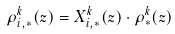<formula> <loc_0><loc_0><loc_500><loc_500>\rho _ { i , * } ^ { k } ( z ) = X _ { i , * } ^ { k } ( z ) \cdot \rho _ { * } ^ { k } ( z )</formula> 